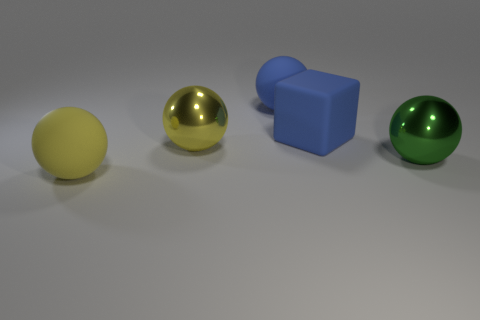Add 2 blue rubber things. How many objects exist? 7 Subtract all cubes. How many objects are left? 4 Subtract all yellow metal objects. Subtract all big green metal spheres. How many objects are left? 3 Add 4 large green balls. How many large green balls are left? 5 Add 1 big blue matte blocks. How many big blue matte blocks exist? 2 Subtract 1 blue balls. How many objects are left? 4 